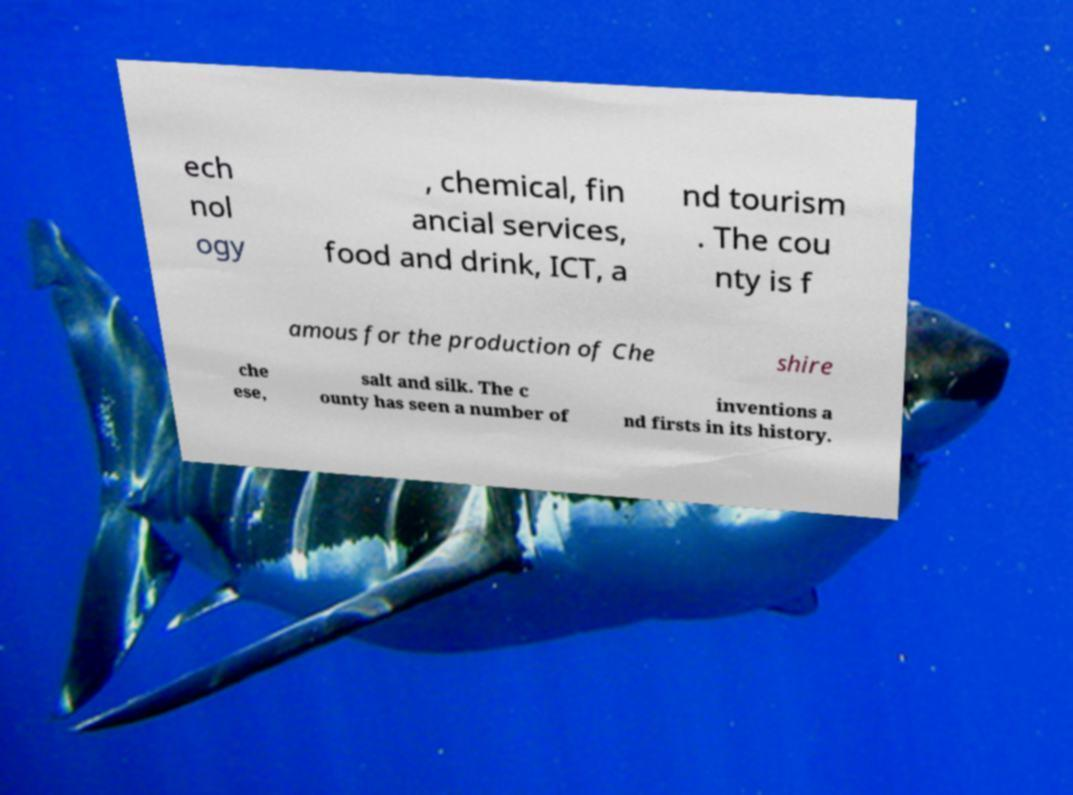Can you read and provide the text displayed in the image?This photo seems to have some interesting text. Can you extract and type it out for me? ech nol ogy , chemical, fin ancial services, food and drink, ICT, a nd tourism . The cou nty is f amous for the production of Che shire che ese, salt and silk. The c ounty has seen a number of inventions a nd firsts in its history. 